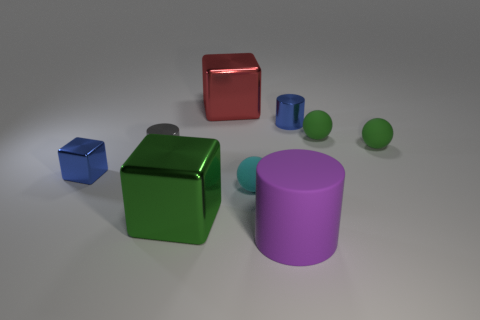How big is the metallic object that is both in front of the big red shiny object and behind the small gray metal cylinder?
Make the answer very short. Small. What material is the green cube in front of the large red metal object?
Offer a terse response. Metal. There is a tiny block; does it have the same color as the metal cylinder to the right of the gray shiny object?
Offer a terse response. Yes. What number of things are metal things in front of the big red thing or small cylinders to the right of the purple rubber cylinder?
Ensure brevity in your answer.  4. There is a cylinder that is behind the cyan rubber sphere and right of the red shiny cube; what color is it?
Your answer should be very brief. Blue. Is the number of big matte objects greater than the number of large blue things?
Your answer should be compact. Yes. There is a tiny blue object behind the gray cylinder; does it have the same shape as the big purple thing?
Ensure brevity in your answer.  Yes. How many metallic objects are either big objects or green spheres?
Keep it short and to the point. 2. Are there any tiny green objects that have the same material as the large green object?
Provide a succinct answer. No. What material is the large purple cylinder?
Offer a very short reply. Rubber. 